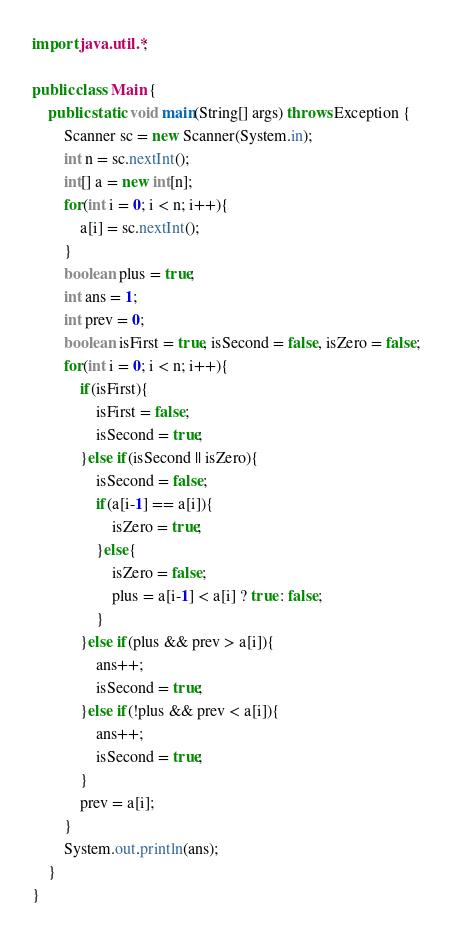Convert code to text. <code><loc_0><loc_0><loc_500><loc_500><_Java_>import java.util.*;

public class Main {
    public static void main(String[] args) throws Exception {
        Scanner sc = new Scanner(System.in);
        int n = sc.nextInt();
        int[] a = new int[n];
        for(int i = 0; i < n; i++){
            a[i] = sc.nextInt();
        }
        boolean plus = true;
        int ans = 1;
        int prev = 0;
        boolean isFirst = true, isSecond = false, isZero = false;
        for(int i = 0; i < n; i++){
            if(isFirst){
                isFirst = false;
                isSecond = true;
            }else if(isSecond || isZero){
                isSecond = false;
                if(a[i-1] == a[i]){
                    isZero = true;
                }else{
                    isZero = false;
                    plus = a[i-1] < a[i] ? true : false;
                }
            }else if(plus && prev > a[i]){
                ans++;
                isSecond = true;
            }else if(!plus && prev < a[i]){
                ans++;
                isSecond = true;
            }
            prev = a[i];
        }
        System.out.println(ans);
    }
}
</code> 